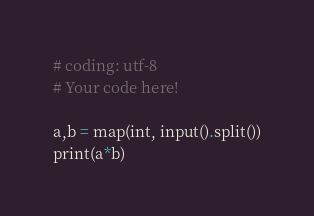<code> <loc_0><loc_0><loc_500><loc_500><_Python_># coding: utf-8
# Your code here!

a,b = map(int, input().split())
print(a*b)</code> 